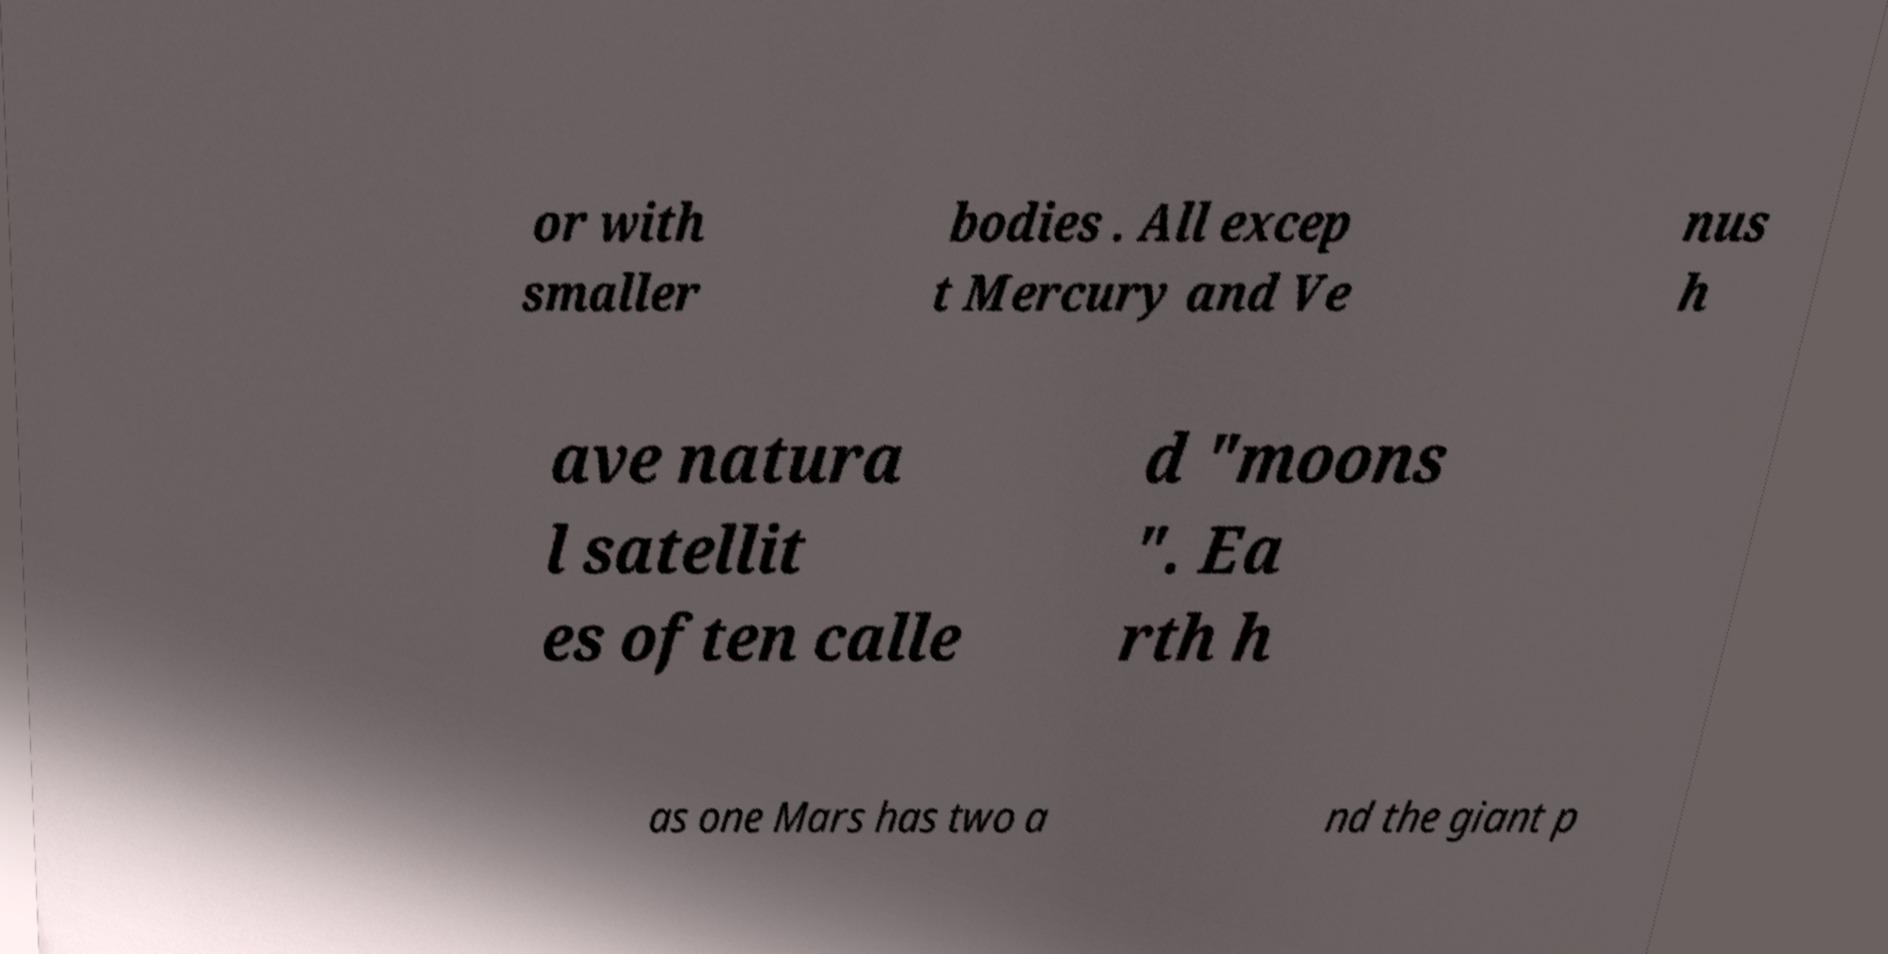What messages or text are displayed in this image? I need them in a readable, typed format. or with smaller bodies . All excep t Mercury and Ve nus h ave natura l satellit es often calle d "moons ". Ea rth h as one Mars has two a nd the giant p 